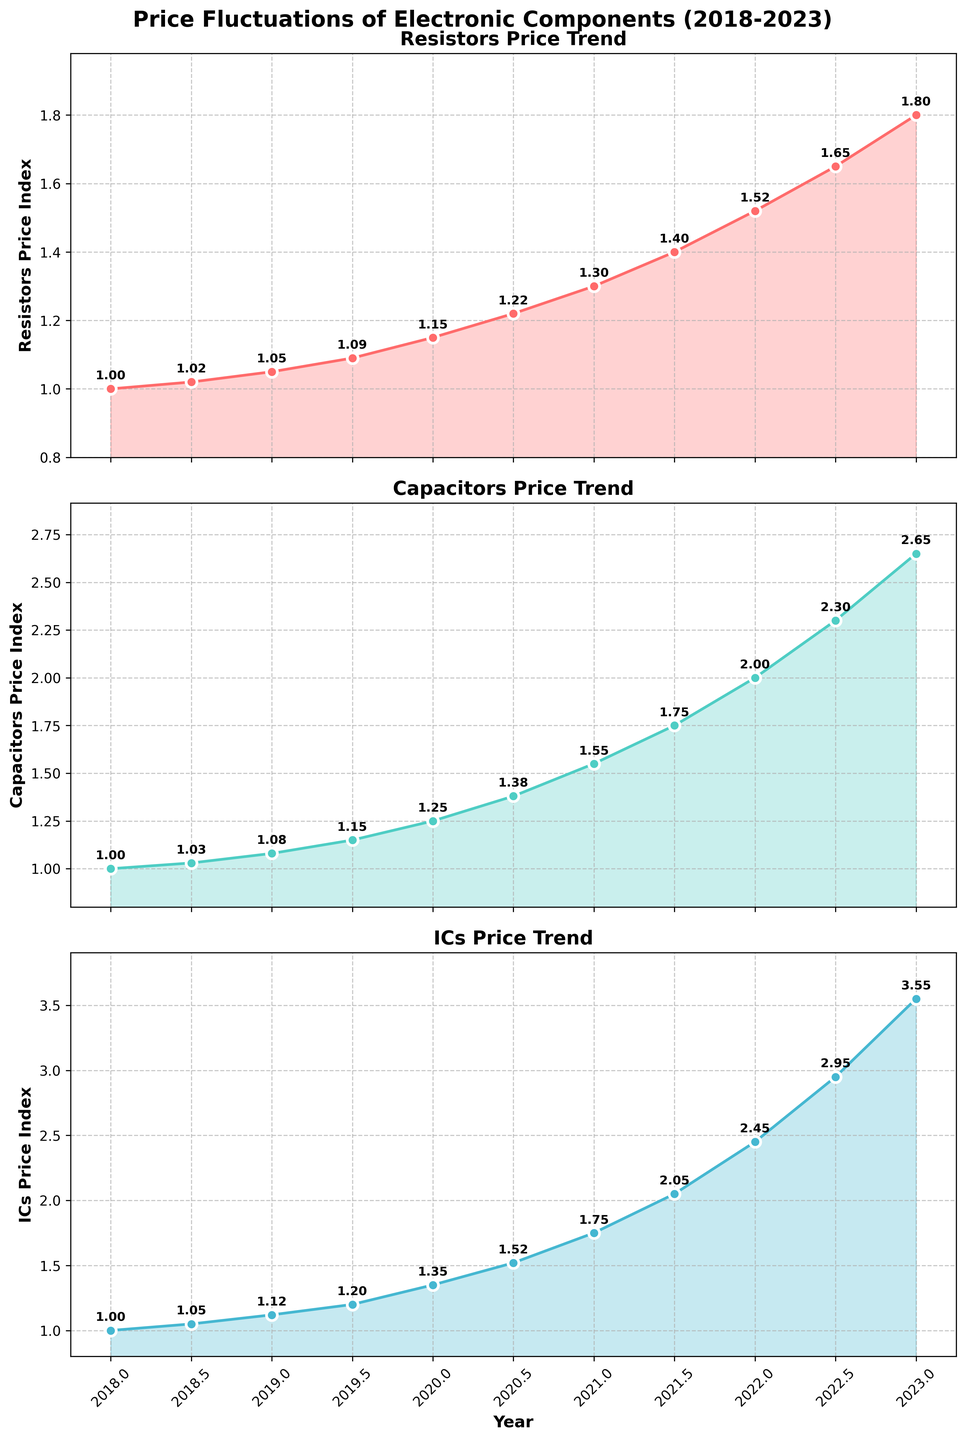What was the price of ICs in 2020? Look at the ICs trend subplot and locate the year 2020 on the x-axis. Check the y-axis value corresponding to 2020.
Answer: 1.35 Which component had the highest price increase between 2021 and 2022? Compare the price in 2021 and 2022 for each component in their subplots. Calculate the increase for Resistors (1.40 to 1.52), Capacitors (1.75 to 2.00), and ICs (2.05 to 2.45). The highest increase is for ICs.
Answer: ICs How much did the price of Capacitors increase from 2018 to 2023? Look at the Capacitors trend subplot and note the values at 2018 (1.00) and 2023 (2.65). Calculate the difference: 2.65 - 1.00.
Answer: 1.65 Among Resistors, Capacitors, and ICs, which had the lowest price point in 2019? Look at the prices for Resistors (1.05), Capacitors (1.08), and ICs (1.12) in 2019 from their respective subplots. The lowest price among them is for Resistors.
Answer: Resistors By what percentage did the price of Resistors change from 2020 to 2021? Note the prices of Resistors in 2020 (1.15) and 2021 (1.30). Calculate the percentage change: ((1.30 - 1.15) / 1.15) * 100%.
Answer: 13.04% How did the prices of Capacitors change in the first half of 2021 compared to the second half? In the Capacitors subplot, compare the prices in early 2021 (1.55) and late 2021 (1.75). Note the increase from 1.55 to 1.75.
Answer: Increased What is the average price of ICs over the entire 5-year period? Sum the price indices for ICs from 2018 to 2023 and divide by the number of data points: (1.00 + 1.05 + 1.12 + 1.20 + 1.35 + 1.52 + 1.75 + 2.05 + 2.45 + 2.95 + 3.55) / 11.
Answer: 1.89 Between which two consecutive years did Capacitors experience the steepest price rise? Look at the Capacitors subplot and calculate the differences: 2018-2018.5 (0.03), 2018.5-2019 (0.05), 2019-2019.5 (0.07), 2019.5-2020 (0.10), 2020-2020.5 (0.13), 2020.5-2021 (0.17), 2021-2021.5 (0.20), 2021.5-2022 (0.25), 2022-2022.5 (0.30), 2022.5-2023 (0.35). The steepest rise is between 2022.5 and 2023.
Answer: 2022.5-2023 